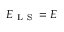<formula> <loc_0><loc_0><loc_500><loc_500>E _ { L S } = E</formula> 